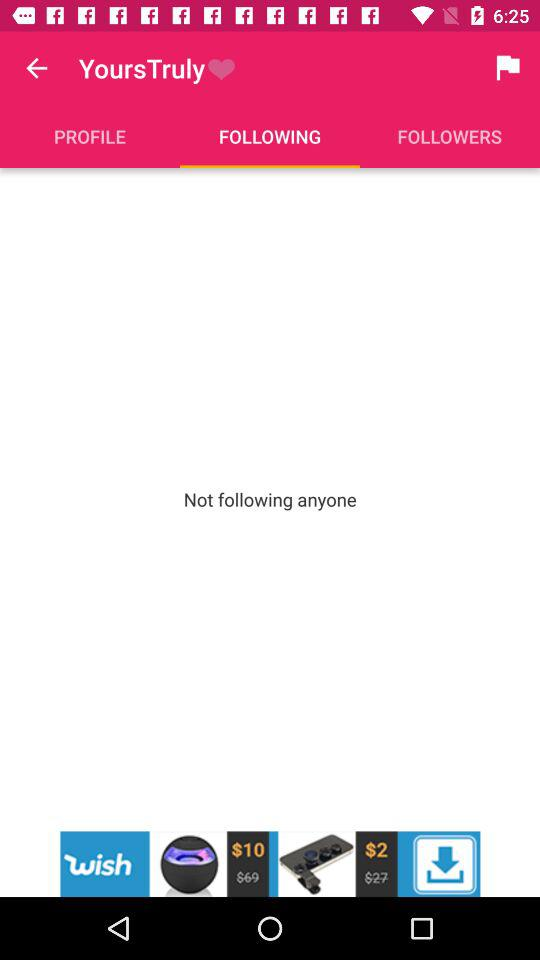How many people is the person following? The person is not following anyone. 